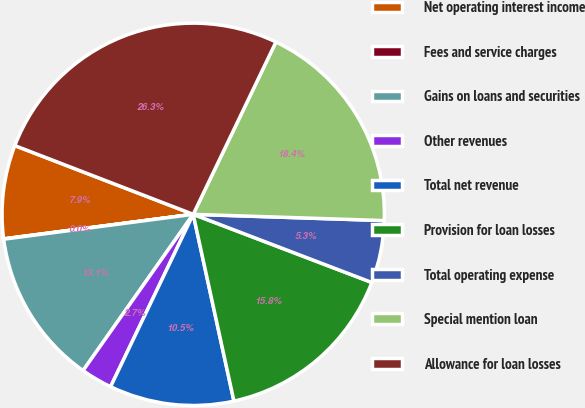<chart> <loc_0><loc_0><loc_500><loc_500><pie_chart><fcel>Net operating interest income<fcel>Fees and service charges<fcel>Gains on loans and securities<fcel>Other revenues<fcel>Total net revenue<fcel>Provision for loan losses<fcel>Total operating expense<fcel>Special mention loan<fcel>Allowance for loan losses<nl><fcel>7.9%<fcel>0.03%<fcel>13.15%<fcel>2.66%<fcel>10.53%<fcel>15.78%<fcel>5.28%<fcel>18.4%<fcel>26.27%<nl></chart> 